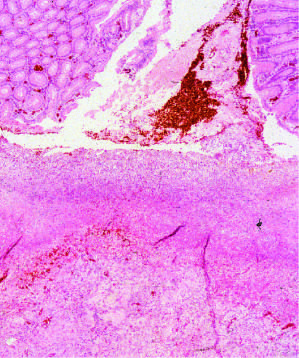what is the necrotic ulcer base composed of?
Answer the question using a single word or phrase. Granulation tissue overlaid by degraded blood 